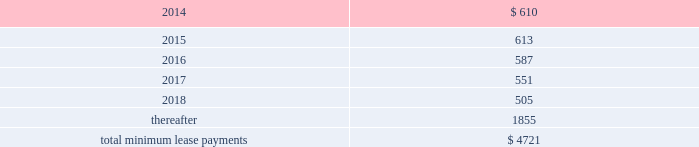Table of contents rent expense under all operating leases , including both cancelable and noncancelable leases , was $ 645 million , $ 488 million and $ 338 million in 2013 , 2012 and 2011 , respectively .
Future minimum lease payments under noncancelable operating leases having remaining terms in excess of one year as of september 28 , 2013 , are as follows ( in millions ) : other commitments as of september 28 , 2013 , the company had outstanding off-balance sheet third-party manufacturing commitments and component purchase commitments of $ 18.6 billion .
In addition to the off-balance sheet commitments mentioned above , the company had outstanding obligations of $ 1.3 billion as of september 28 , 2013 , which consisted mainly of commitments to acquire capital assets , including product tooling and manufacturing process equipment , and commitments related to advertising , research and development , internet and telecommunications services and other obligations .
Contingencies the company is subject to various legal proceedings and claims that have arisen in the ordinary course of business and that have not been fully adjudicated .
In the opinion of management , there was not at least a reasonable possibility the company may have incurred a material loss , or a material loss in excess of a recorded accrual , with respect to loss contingencies .
However , the outcome of litigation is inherently uncertain .
Therefore , although management considers the likelihood of such an outcome to be remote , if one or more of these legal matters were resolved against the company in a reporting period for amounts in excess of management 2019s expectations , the company 2019s consolidated financial statements for that reporting period could be materially adversely affected .
Apple inc .
Samsung electronics co. , ltd , et al .
On august 24 , 2012 , a jury returned a verdict awarding the company $ 1.05 billion in its lawsuit against samsung electronics co. , ltd and affiliated parties in the united states district court , northern district of california , san jose division .
On march 1 , 2013 , the district court upheld $ 599 million of the jury 2019s award and ordered a new trial as to the remainder .
Because the award is subject to entry of final judgment , partial re-trial and appeal , the company has not recognized the award in its results of operations .
Virnetx , inc .
Apple inc .
Et al .
On august 11 , 2010 , virnetx , inc .
Filed an action against the company alleging that certain of its products infringed on four patents relating to network communications technology .
On november 6 , 2012 , a jury returned a verdict against the company , and awarded damages of $ 368 million .
The company is challenging the verdict , believes it has valid defenses and has not recorded a loss accrual at this time. .

Of the total minimum lease payments , what percentage were due after 2018? 
Computations: (1855 / 4721)
Answer: 0.39293. 